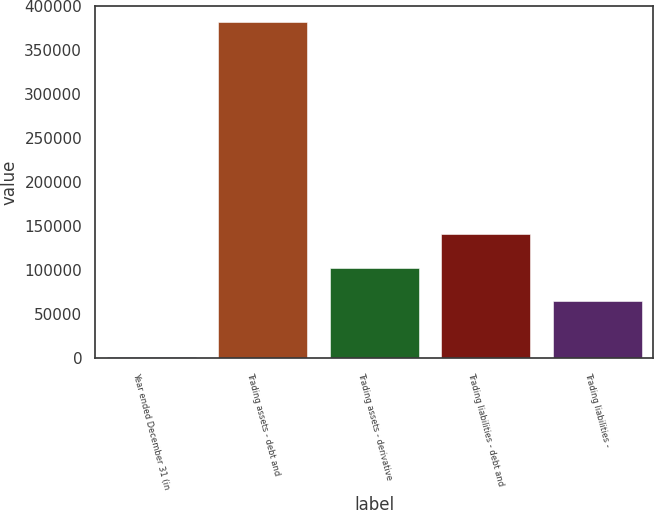Convert chart. <chart><loc_0><loc_0><loc_500><loc_500><bar_chart><fcel>Year ended December 31 (in<fcel>Trading assets - debt and<fcel>Trading assets - derivative<fcel>Trading liabilities - debt and<fcel>Trading liabilities -<nl><fcel>2007<fcel>381415<fcel>103139<fcel>141080<fcel>65198<nl></chart> 